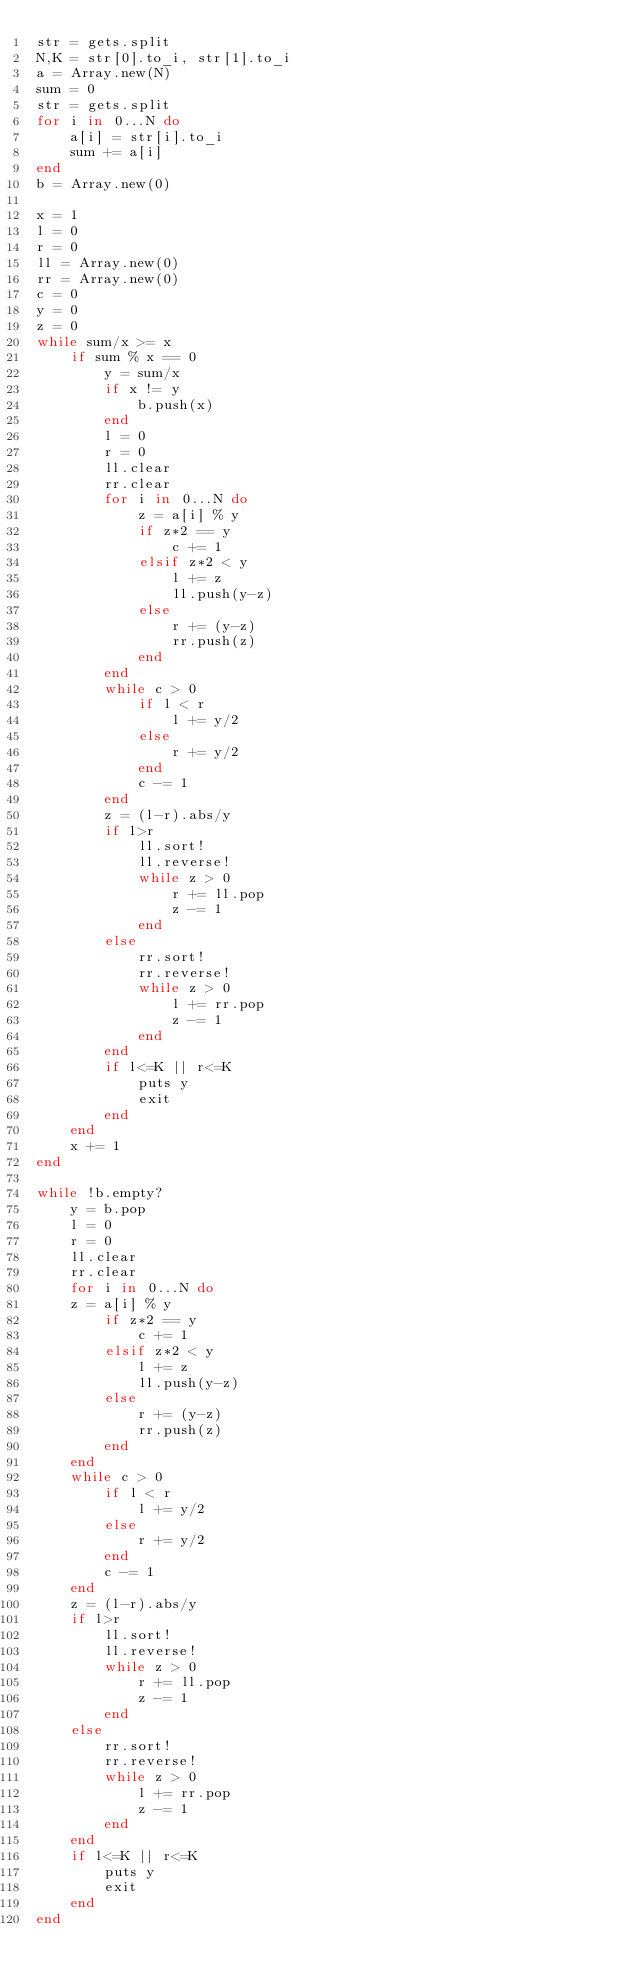Convert code to text. <code><loc_0><loc_0><loc_500><loc_500><_Ruby_>str = gets.split
N,K = str[0].to_i, str[1].to_i
a = Array.new(N)
sum = 0
str = gets.split
for i in 0...N do
    a[i] = str[i].to_i
    sum += a[i]
end
b = Array.new(0)

x = 1
l = 0
r = 0
ll = Array.new(0)
rr = Array.new(0)
c = 0
y = 0
z = 0
while sum/x >= x
    if sum % x == 0
        y = sum/x
        if x != y
            b.push(x) 
        end
        l = 0
        r = 0
        ll.clear
        rr.clear
        for i in 0...N do
            z = a[i] % y
            if z*2 == y
                c += 1
            elsif z*2 < y
                l += z
                ll.push(y-z)
            else
                r += (y-z)
                rr.push(z)
            end
        end
        while c > 0
            if l < r
                l += y/2
            else
                r += y/2
            end
            c -= 1
        end
        z = (l-r).abs/y
        if l>r
            ll.sort!
            ll.reverse!
            while z > 0
                r += ll.pop
                z -= 1
            end
        else
            rr.sort!
            rr.reverse!
            while z > 0
                l += rr.pop
                z -= 1
            end
        end
        if l<=K || r<=K
            puts y
            exit
        end
    end
    x += 1
end

while !b.empty?
    y = b.pop
    l = 0
    r = 0
    ll.clear
    rr.clear
    for i in 0...N do
    z = a[i] % y
        if z*2 == y
            c += 1
        elsif z*2 < y
            l += z
            ll.push(y-z)
        else
            r += (y-z)
            rr.push(z)
        end
    end
    while c > 0
        if l < r
            l += y/2
        else
            r += y/2
        end
        c -= 1
    end
    z = (l-r).abs/y
    if l>r
        ll.sort!
        ll.reverse!
        while z > 0
            r += ll.pop
            z -= 1
        end
    else
        rr.sort!
        rr.reverse!
        while z > 0
            l += rr.pop
            z -= 1
        end
    end
    if l<=K || r<=K
        puts y
        exit
    end
end</code> 